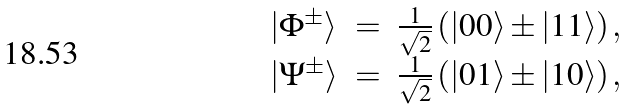Convert formula to latex. <formula><loc_0><loc_0><loc_500><loc_500>\begin{array} { l c r } \left | { \Phi } ^ { \pm } \right \rangle & = & \frac { 1 } { \sqrt { 2 } } \left ( \left | 0 0 \right \rangle \pm \left | 1 1 \right \rangle \right ) , \\ \left | { \Psi } ^ { \pm } \right \rangle & = & \frac { 1 } { \sqrt { 2 } } \left ( \left | 0 1 \right \rangle \pm \left | 1 0 \right \rangle \right ) , \\ \end{array}</formula> 